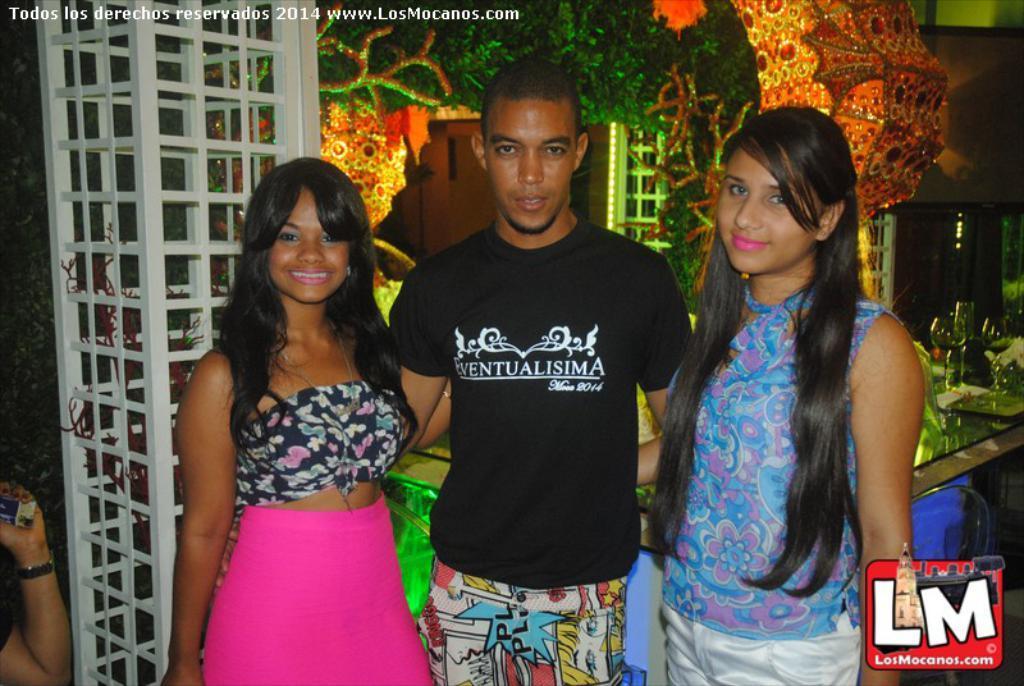Describe this image in one or two sentences. In this image we can see a man and two girls are standing. Man is wearing black t-shirt. One girl is wearing blue dress, the other one is wearing black and pink color dress. Behind them one table is there, on table glasses are present and some decoration is there. Left side of the image one white color pillar is present. 